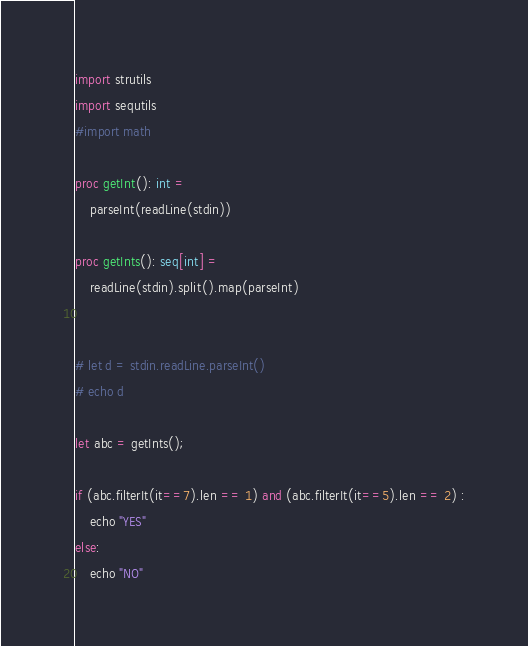<code> <loc_0><loc_0><loc_500><loc_500><_Nim_>import strutils
import sequtils
#import math

proc getInt(): int =
    parseInt(readLine(stdin))

proc getInts(): seq[int] =
    readLine(stdin).split().map(parseInt)


# let d = stdin.readLine.parseInt()
# echo d

let abc = getInts();

if (abc.filterIt(it==7).len == 1) and (abc.filterIt(it==5).len == 2) :
    echo "YES"
else:
    echo "NO"</code> 